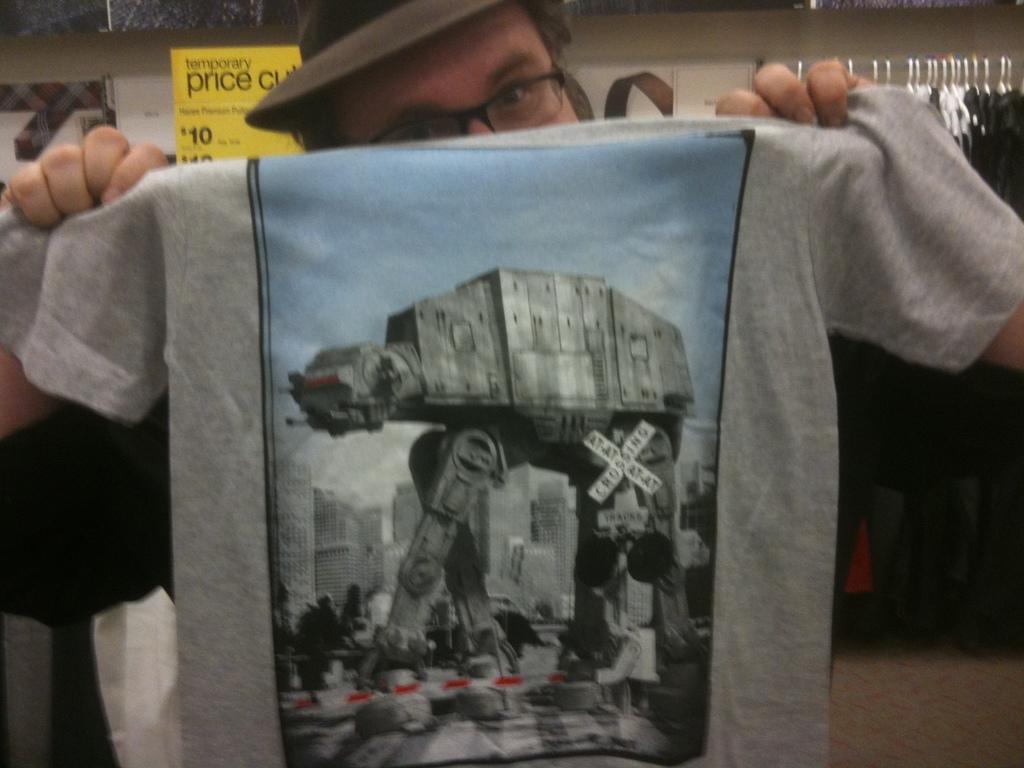Describe this image in one or two sentences. This image consists of a man holding a T-shirt. In the background, there are many clothes hanged. And we can see a price board in yellow color. 